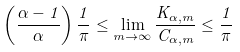<formula> <loc_0><loc_0><loc_500><loc_500>\left ( \frac { \alpha - 1 } { \alpha } \right ) \frac { 1 } { \pi } \leq \lim _ { m \rightarrow \infty } \frac { K _ { \alpha , m } } { C _ { \alpha , m } } \leq \frac { 1 } { \pi }</formula> 